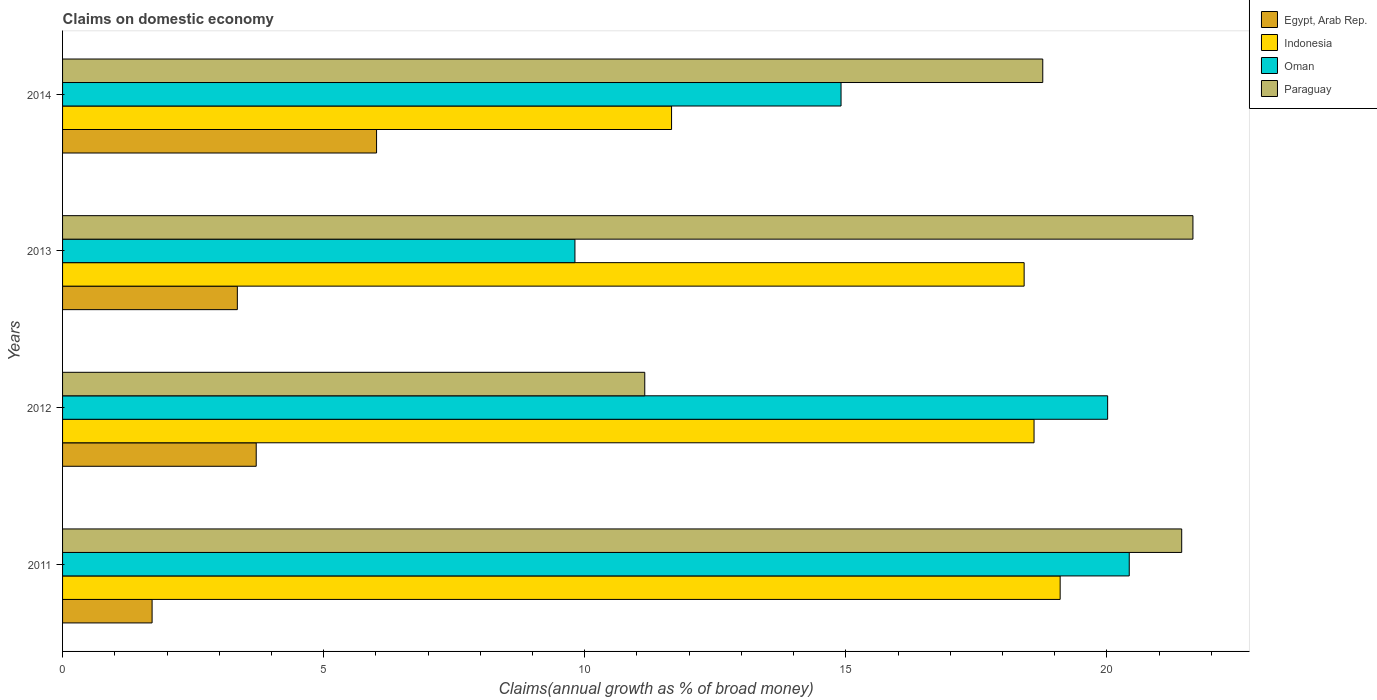How many different coloured bars are there?
Ensure brevity in your answer.  4. How many groups of bars are there?
Give a very brief answer. 4. Are the number of bars per tick equal to the number of legend labels?
Keep it short and to the point. Yes. How many bars are there on the 2nd tick from the top?
Your answer should be very brief. 4. What is the label of the 1st group of bars from the top?
Your answer should be very brief. 2014. What is the percentage of broad money claimed on domestic economy in Paraguay in 2011?
Your response must be concise. 21.43. Across all years, what is the maximum percentage of broad money claimed on domestic economy in Oman?
Keep it short and to the point. 20.43. Across all years, what is the minimum percentage of broad money claimed on domestic economy in Indonesia?
Ensure brevity in your answer.  11.66. In which year was the percentage of broad money claimed on domestic economy in Indonesia maximum?
Your response must be concise. 2011. What is the total percentage of broad money claimed on domestic economy in Egypt, Arab Rep. in the graph?
Give a very brief answer. 14.78. What is the difference between the percentage of broad money claimed on domestic economy in Indonesia in 2011 and that in 2014?
Your answer should be very brief. 7.44. What is the difference between the percentage of broad money claimed on domestic economy in Indonesia in 2014 and the percentage of broad money claimed on domestic economy in Oman in 2013?
Make the answer very short. 1.85. What is the average percentage of broad money claimed on domestic economy in Indonesia per year?
Ensure brevity in your answer.  16.95. In the year 2012, what is the difference between the percentage of broad money claimed on domestic economy in Indonesia and percentage of broad money claimed on domestic economy in Paraguay?
Your answer should be compact. 7.46. In how many years, is the percentage of broad money claimed on domestic economy in Oman greater than 4 %?
Ensure brevity in your answer.  4. What is the ratio of the percentage of broad money claimed on domestic economy in Egypt, Arab Rep. in 2012 to that in 2014?
Give a very brief answer. 0.62. What is the difference between the highest and the second highest percentage of broad money claimed on domestic economy in Indonesia?
Keep it short and to the point. 0.5. What is the difference between the highest and the lowest percentage of broad money claimed on domestic economy in Paraguay?
Your answer should be very brief. 10.5. Is the sum of the percentage of broad money claimed on domestic economy in Paraguay in 2013 and 2014 greater than the maximum percentage of broad money claimed on domestic economy in Indonesia across all years?
Make the answer very short. Yes. Is it the case that in every year, the sum of the percentage of broad money claimed on domestic economy in Oman and percentage of broad money claimed on domestic economy in Indonesia is greater than the sum of percentage of broad money claimed on domestic economy in Paraguay and percentage of broad money claimed on domestic economy in Egypt, Arab Rep.?
Your answer should be very brief. No. What does the 1st bar from the top in 2014 represents?
Offer a very short reply. Paraguay. What does the 4th bar from the bottom in 2011 represents?
Provide a short and direct response. Paraguay. Are the values on the major ticks of X-axis written in scientific E-notation?
Ensure brevity in your answer.  No. Does the graph contain grids?
Your response must be concise. No. How many legend labels are there?
Make the answer very short. 4. What is the title of the graph?
Your answer should be compact. Claims on domestic economy. What is the label or title of the X-axis?
Your answer should be very brief. Claims(annual growth as % of broad money). What is the Claims(annual growth as % of broad money) of Egypt, Arab Rep. in 2011?
Keep it short and to the point. 1.71. What is the Claims(annual growth as % of broad money) of Indonesia in 2011?
Make the answer very short. 19.1. What is the Claims(annual growth as % of broad money) of Oman in 2011?
Offer a terse response. 20.43. What is the Claims(annual growth as % of broad money) of Paraguay in 2011?
Keep it short and to the point. 21.43. What is the Claims(annual growth as % of broad money) in Egypt, Arab Rep. in 2012?
Your response must be concise. 3.71. What is the Claims(annual growth as % of broad money) of Indonesia in 2012?
Provide a short and direct response. 18.6. What is the Claims(annual growth as % of broad money) of Oman in 2012?
Offer a terse response. 20.01. What is the Claims(annual growth as % of broad money) in Paraguay in 2012?
Make the answer very short. 11.15. What is the Claims(annual growth as % of broad money) of Egypt, Arab Rep. in 2013?
Your response must be concise. 3.35. What is the Claims(annual growth as % of broad money) of Indonesia in 2013?
Offer a very short reply. 18.42. What is the Claims(annual growth as % of broad money) in Oman in 2013?
Your answer should be very brief. 9.81. What is the Claims(annual growth as % of broad money) of Paraguay in 2013?
Give a very brief answer. 21.65. What is the Claims(annual growth as % of broad money) in Egypt, Arab Rep. in 2014?
Your response must be concise. 6.01. What is the Claims(annual growth as % of broad money) in Indonesia in 2014?
Provide a short and direct response. 11.66. What is the Claims(annual growth as % of broad money) of Oman in 2014?
Ensure brevity in your answer.  14.91. What is the Claims(annual growth as % of broad money) in Paraguay in 2014?
Your response must be concise. 18.77. Across all years, what is the maximum Claims(annual growth as % of broad money) of Egypt, Arab Rep.?
Provide a short and direct response. 6.01. Across all years, what is the maximum Claims(annual growth as % of broad money) in Indonesia?
Your response must be concise. 19.1. Across all years, what is the maximum Claims(annual growth as % of broad money) in Oman?
Make the answer very short. 20.43. Across all years, what is the maximum Claims(annual growth as % of broad money) in Paraguay?
Make the answer very short. 21.65. Across all years, what is the minimum Claims(annual growth as % of broad money) of Egypt, Arab Rep.?
Your response must be concise. 1.71. Across all years, what is the minimum Claims(annual growth as % of broad money) in Indonesia?
Your answer should be compact. 11.66. Across all years, what is the minimum Claims(annual growth as % of broad money) of Oman?
Make the answer very short. 9.81. Across all years, what is the minimum Claims(annual growth as % of broad money) of Paraguay?
Offer a terse response. 11.15. What is the total Claims(annual growth as % of broad money) of Egypt, Arab Rep. in the graph?
Offer a very short reply. 14.78. What is the total Claims(annual growth as % of broad money) of Indonesia in the graph?
Your answer should be very brief. 67.79. What is the total Claims(annual growth as % of broad money) in Oman in the graph?
Your response must be concise. 65.16. What is the total Claims(annual growth as % of broad money) in Paraguay in the graph?
Your answer should be very brief. 73. What is the difference between the Claims(annual growth as % of broad money) in Egypt, Arab Rep. in 2011 and that in 2012?
Make the answer very short. -1.99. What is the difference between the Claims(annual growth as % of broad money) in Oman in 2011 and that in 2012?
Offer a terse response. 0.41. What is the difference between the Claims(annual growth as % of broad money) of Paraguay in 2011 and that in 2012?
Your response must be concise. 10.28. What is the difference between the Claims(annual growth as % of broad money) in Egypt, Arab Rep. in 2011 and that in 2013?
Your response must be concise. -1.63. What is the difference between the Claims(annual growth as % of broad money) of Indonesia in 2011 and that in 2013?
Keep it short and to the point. 0.69. What is the difference between the Claims(annual growth as % of broad money) of Oman in 2011 and that in 2013?
Provide a short and direct response. 10.62. What is the difference between the Claims(annual growth as % of broad money) of Paraguay in 2011 and that in 2013?
Provide a short and direct response. -0.22. What is the difference between the Claims(annual growth as % of broad money) of Egypt, Arab Rep. in 2011 and that in 2014?
Your response must be concise. -4.3. What is the difference between the Claims(annual growth as % of broad money) in Indonesia in 2011 and that in 2014?
Keep it short and to the point. 7.44. What is the difference between the Claims(annual growth as % of broad money) in Oman in 2011 and that in 2014?
Give a very brief answer. 5.52. What is the difference between the Claims(annual growth as % of broad money) in Paraguay in 2011 and that in 2014?
Offer a very short reply. 2.66. What is the difference between the Claims(annual growth as % of broad money) of Egypt, Arab Rep. in 2012 and that in 2013?
Offer a very short reply. 0.36. What is the difference between the Claims(annual growth as % of broad money) of Indonesia in 2012 and that in 2013?
Provide a short and direct response. 0.19. What is the difference between the Claims(annual growth as % of broad money) in Oman in 2012 and that in 2013?
Your answer should be compact. 10.2. What is the difference between the Claims(annual growth as % of broad money) in Paraguay in 2012 and that in 2013?
Your answer should be compact. -10.5. What is the difference between the Claims(annual growth as % of broad money) of Egypt, Arab Rep. in 2012 and that in 2014?
Offer a very short reply. -2.3. What is the difference between the Claims(annual growth as % of broad money) in Indonesia in 2012 and that in 2014?
Offer a very short reply. 6.94. What is the difference between the Claims(annual growth as % of broad money) of Oman in 2012 and that in 2014?
Offer a very short reply. 5.11. What is the difference between the Claims(annual growth as % of broad money) of Paraguay in 2012 and that in 2014?
Your response must be concise. -7.62. What is the difference between the Claims(annual growth as % of broad money) in Egypt, Arab Rep. in 2013 and that in 2014?
Your response must be concise. -2.67. What is the difference between the Claims(annual growth as % of broad money) in Indonesia in 2013 and that in 2014?
Offer a terse response. 6.75. What is the difference between the Claims(annual growth as % of broad money) in Oman in 2013 and that in 2014?
Provide a short and direct response. -5.1. What is the difference between the Claims(annual growth as % of broad money) in Paraguay in 2013 and that in 2014?
Your answer should be compact. 2.88. What is the difference between the Claims(annual growth as % of broad money) in Egypt, Arab Rep. in 2011 and the Claims(annual growth as % of broad money) in Indonesia in 2012?
Offer a very short reply. -16.89. What is the difference between the Claims(annual growth as % of broad money) in Egypt, Arab Rep. in 2011 and the Claims(annual growth as % of broad money) in Oman in 2012?
Make the answer very short. -18.3. What is the difference between the Claims(annual growth as % of broad money) of Egypt, Arab Rep. in 2011 and the Claims(annual growth as % of broad money) of Paraguay in 2012?
Provide a succinct answer. -9.44. What is the difference between the Claims(annual growth as % of broad money) of Indonesia in 2011 and the Claims(annual growth as % of broad money) of Oman in 2012?
Offer a very short reply. -0.91. What is the difference between the Claims(annual growth as % of broad money) of Indonesia in 2011 and the Claims(annual growth as % of broad money) of Paraguay in 2012?
Your response must be concise. 7.96. What is the difference between the Claims(annual growth as % of broad money) in Oman in 2011 and the Claims(annual growth as % of broad money) in Paraguay in 2012?
Ensure brevity in your answer.  9.28. What is the difference between the Claims(annual growth as % of broad money) in Egypt, Arab Rep. in 2011 and the Claims(annual growth as % of broad money) in Indonesia in 2013?
Provide a succinct answer. -16.7. What is the difference between the Claims(annual growth as % of broad money) of Egypt, Arab Rep. in 2011 and the Claims(annual growth as % of broad money) of Oman in 2013?
Your answer should be compact. -8.1. What is the difference between the Claims(annual growth as % of broad money) in Egypt, Arab Rep. in 2011 and the Claims(annual growth as % of broad money) in Paraguay in 2013?
Ensure brevity in your answer.  -19.93. What is the difference between the Claims(annual growth as % of broad money) in Indonesia in 2011 and the Claims(annual growth as % of broad money) in Oman in 2013?
Keep it short and to the point. 9.29. What is the difference between the Claims(annual growth as % of broad money) in Indonesia in 2011 and the Claims(annual growth as % of broad money) in Paraguay in 2013?
Your answer should be compact. -2.54. What is the difference between the Claims(annual growth as % of broad money) of Oman in 2011 and the Claims(annual growth as % of broad money) of Paraguay in 2013?
Offer a terse response. -1.22. What is the difference between the Claims(annual growth as % of broad money) in Egypt, Arab Rep. in 2011 and the Claims(annual growth as % of broad money) in Indonesia in 2014?
Keep it short and to the point. -9.95. What is the difference between the Claims(annual growth as % of broad money) of Egypt, Arab Rep. in 2011 and the Claims(annual growth as % of broad money) of Oman in 2014?
Keep it short and to the point. -13.19. What is the difference between the Claims(annual growth as % of broad money) of Egypt, Arab Rep. in 2011 and the Claims(annual growth as % of broad money) of Paraguay in 2014?
Provide a short and direct response. -17.06. What is the difference between the Claims(annual growth as % of broad money) of Indonesia in 2011 and the Claims(annual growth as % of broad money) of Oman in 2014?
Provide a succinct answer. 4.2. What is the difference between the Claims(annual growth as % of broad money) in Indonesia in 2011 and the Claims(annual growth as % of broad money) in Paraguay in 2014?
Your answer should be very brief. 0.33. What is the difference between the Claims(annual growth as % of broad money) of Oman in 2011 and the Claims(annual growth as % of broad money) of Paraguay in 2014?
Make the answer very short. 1.66. What is the difference between the Claims(annual growth as % of broad money) of Egypt, Arab Rep. in 2012 and the Claims(annual growth as % of broad money) of Indonesia in 2013?
Your answer should be very brief. -14.71. What is the difference between the Claims(annual growth as % of broad money) in Egypt, Arab Rep. in 2012 and the Claims(annual growth as % of broad money) in Oman in 2013?
Keep it short and to the point. -6.1. What is the difference between the Claims(annual growth as % of broad money) in Egypt, Arab Rep. in 2012 and the Claims(annual growth as % of broad money) in Paraguay in 2013?
Your response must be concise. -17.94. What is the difference between the Claims(annual growth as % of broad money) of Indonesia in 2012 and the Claims(annual growth as % of broad money) of Oman in 2013?
Ensure brevity in your answer.  8.79. What is the difference between the Claims(annual growth as % of broad money) in Indonesia in 2012 and the Claims(annual growth as % of broad money) in Paraguay in 2013?
Offer a very short reply. -3.04. What is the difference between the Claims(annual growth as % of broad money) in Oman in 2012 and the Claims(annual growth as % of broad money) in Paraguay in 2013?
Keep it short and to the point. -1.63. What is the difference between the Claims(annual growth as % of broad money) of Egypt, Arab Rep. in 2012 and the Claims(annual growth as % of broad money) of Indonesia in 2014?
Provide a succinct answer. -7.95. What is the difference between the Claims(annual growth as % of broad money) of Egypt, Arab Rep. in 2012 and the Claims(annual growth as % of broad money) of Oman in 2014?
Make the answer very short. -11.2. What is the difference between the Claims(annual growth as % of broad money) in Egypt, Arab Rep. in 2012 and the Claims(annual growth as % of broad money) in Paraguay in 2014?
Ensure brevity in your answer.  -15.06. What is the difference between the Claims(annual growth as % of broad money) in Indonesia in 2012 and the Claims(annual growth as % of broad money) in Oman in 2014?
Your answer should be compact. 3.7. What is the difference between the Claims(annual growth as % of broad money) of Indonesia in 2012 and the Claims(annual growth as % of broad money) of Paraguay in 2014?
Make the answer very short. -0.17. What is the difference between the Claims(annual growth as % of broad money) in Oman in 2012 and the Claims(annual growth as % of broad money) in Paraguay in 2014?
Your answer should be very brief. 1.24. What is the difference between the Claims(annual growth as % of broad money) of Egypt, Arab Rep. in 2013 and the Claims(annual growth as % of broad money) of Indonesia in 2014?
Ensure brevity in your answer.  -8.32. What is the difference between the Claims(annual growth as % of broad money) in Egypt, Arab Rep. in 2013 and the Claims(annual growth as % of broad money) in Oman in 2014?
Your answer should be very brief. -11.56. What is the difference between the Claims(annual growth as % of broad money) in Egypt, Arab Rep. in 2013 and the Claims(annual growth as % of broad money) in Paraguay in 2014?
Provide a short and direct response. -15.42. What is the difference between the Claims(annual growth as % of broad money) of Indonesia in 2013 and the Claims(annual growth as % of broad money) of Oman in 2014?
Your response must be concise. 3.51. What is the difference between the Claims(annual growth as % of broad money) of Indonesia in 2013 and the Claims(annual growth as % of broad money) of Paraguay in 2014?
Your answer should be very brief. -0.36. What is the difference between the Claims(annual growth as % of broad money) of Oman in 2013 and the Claims(annual growth as % of broad money) of Paraguay in 2014?
Offer a very short reply. -8.96. What is the average Claims(annual growth as % of broad money) of Egypt, Arab Rep. per year?
Provide a short and direct response. 3.7. What is the average Claims(annual growth as % of broad money) of Indonesia per year?
Ensure brevity in your answer.  16.95. What is the average Claims(annual growth as % of broad money) in Oman per year?
Ensure brevity in your answer.  16.29. What is the average Claims(annual growth as % of broad money) of Paraguay per year?
Offer a very short reply. 18.25. In the year 2011, what is the difference between the Claims(annual growth as % of broad money) of Egypt, Arab Rep. and Claims(annual growth as % of broad money) of Indonesia?
Make the answer very short. -17.39. In the year 2011, what is the difference between the Claims(annual growth as % of broad money) of Egypt, Arab Rep. and Claims(annual growth as % of broad money) of Oman?
Give a very brief answer. -18.71. In the year 2011, what is the difference between the Claims(annual growth as % of broad money) of Egypt, Arab Rep. and Claims(annual growth as % of broad money) of Paraguay?
Your answer should be compact. -19.72. In the year 2011, what is the difference between the Claims(annual growth as % of broad money) in Indonesia and Claims(annual growth as % of broad money) in Oman?
Provide a succinct answer. -1.32. In the year 2011, what is the difference between the Claims(annual growth as % of broad money) of Indonesia and Claims(annual growth as % of broad money) of Paraguay?
Ensure brevity in your answer.  -2.33. In the year 2011, what is the difference between the Claims(annual growth as % of broad money) in Oman and Claims(annual growth as % of broad money) in Paraguay?
Your answer should be compact. -1. In the year 2012, what is the difference between the Claims(annual growth as % of broad money) of Egypt, Arab Rep. and Claims(annual growth as % of broad money) of Indonesia?
Offer a terse response. -14.9. In the year 2012, what is the difference between the Claims(annual growth as % of broad money) of Egypt, Arab Rep. and Claims(annual growth as % of broad money) of Oman?
Your answer should be compact. -16.31. In the year 2012, what is the difference between the Claims(annual growth as % of broad money) in Egypt, Arab Rep. and Claims(annual growth as % of broad money) in Paraguay?
Keep it short and to the point. -7.44. In the year 2012, what is the difference between the Claims(annual growth as % of broad money) in Indonesia and Claims(annual growth as % of broad money) in Oman?
Ensure brevity in your answer.  -1.41. In the year 2012, what is the difference between the Claims(annual growth as % of broad money) in Indonesia and Claims(annual growth as % of broad money) in Paraguay?
Your answer should be very brief. 7.46. In the year 2012, what is the difference between the Claims(annual growth as % of broad money) of Oman and Claims(annual growth as % of broad money) of Paraguay?
Your response must be concise. 8.86. In the year 2013, what is the difference between the Claims(annual growth as % of broad money) of Egypt, Arab Rep. and Claims(annual growth as % of broad money) of Indonesia?
Give a very brief answer. -15.07. In the year 2013, what is the difference between the Claims(annual growth as % of broad money) of Egypt, Arab Rep. and Claims(annual growth as % of broad money) of Oman?
Your response must be concise. -6.47. In the year 2013, what is the difference between the Claims(annual growth as % of broad money) in Egypt, Arab Rep. and Claims(annual growth as % of broad money) in Paraguay?
Make the answer very short. -18.3. In the year 2013, what is the difference between the Claims(annual growth as % of broad money) of Indonesia and Claims(annual growth as % of broad money) of Oman?
Ensure brevity in your answer.  8.6. In the year 2013, what is the difference between the Claims(annual growth as % of broad money) of Indonesia and Claims(annual growth as % of broad money) of Paraguay?
Offer a very short reply. -3.23. In the year 2013, what is the difference between the Claims(annual growth as % of broad money) in Oman and Claims(annual growth as % of broad money) in Paraguay?
Your response must be concise. -11.84. In the year 2014, what is the difference between the Claims(annual growth as % of broad money) in Egypt, Arab Rep. and Claims(annual growth as % of broad money) in Indonesia?
Your answer should be compact. -5.65. In the year 2014, what is the difference between the Claims(annual growth as % of broad money) of Egypt, Arab Rep. and Claims(annual growth as % of broad money) of Oman?
Give a very brief answer. -8.9. In the year 2014, what is the difference between the Claims(annual growth as % of broad money) of Egypt, Arab Rep. and Claims(annual growth as % of broad money) of Paraguay?
Offer a terse response. -12.76. In the year 2014, what is the difference between the Claims(annual growth as % of broad money) in Indonesia and Claims(annual growth as % of broad money) in Oman?
Ensure brevity in your answer.  -3.25. In the year 2014, what is the difference between the Claims(annual growth as % of broad money) of Indonesia and Claims(annual growth as % of broad money) of Paraguay?
Provide a short and direct response. -7.11. In the year 2014, what is the difference between the Claims(annual growth as % of broad money) in Oman and Claims(annual growth as % of broad money) in Paraguay?
Your answer should be compact. -3.86. What is the ratio of the Claims(annual growth as % of broad money) of Egypt, Arab Rep. in 2011 to that in 2012?
Keep it short and to the point. 0.46. What is the ratio of the Claims(annual growth as % of broad money) in Indonesia in 2011 to that in 2012?
Your answer should be very brief. 1.03. What is the ratio of the Claims(annual growth as % of broad money) of Oman in 2011 to that in 2012?
Your answer should be compact. 1.02. What is the ratio of the Claims(annual growth as % of broad money) of Paraguay in 2011 to that in 2012?
Provide a short and direct response. 1.92. What is the ratio of the Claims(annual growth as % of broad money) of Egypt, Arab Rep. in 2011 to that in 2013?
Ensure brevity in your answer.  0.51. What is the ratio of the Claims(annual growth as % of broad money) in Indonesia in 2011 to that in 2013?
Make the answer very short. 1.04. What is the ratio of the Claims(annual growth as % of broad money) in Oman in 2011 to that in 2013?
Your answer should be compact. 2.08. What is the ratio of the Claims(annual growth as % of broad money) in Paraguay in 2011 to that in 2013?
Your response must be concise. 0.99. What is the ratio of the Claims(annual growth as % of broad money) of Egypt, Arab Rep. in 2011 to that in 2014?
Ensure brevity in your answer.  0.29. What is the ratio of the Claims(annual growth as % of broad money) in Indonesia in 2011 to that in 2014?
Give a very brief answer. 1.64. What is the ratio of the Claims(annual growth as % of broad money) of Oman in 2011 to that in 2014?
Provide a short and direct response. 1.37. What is the ratio of the Claims(annual growth as % of broad money) in Paraguay in 2011 to that in 2014?
Give a very brief answer. 1.14. What is the ratio of the Claims(annual growth as % of broad money) in Egypt, Arab Rep. in 2012 to that in 2013?
Give a very brief answer. 1.11. What is the ratio of the Claims(annual growth as % of broad money) in Indonesia in 2012 to that in 2013?
Provide a succinct answer. 1.01. What is the ratio of the Claims(annual growth as % of broad money) of Oman in 2012 to that in 2013?
Provide a short and direct response. 2.04. What is the ratio of the Claims(annual growth as % of broad money) in Paraguay in 2012 to that in 2013?
Ensure brevity in your answer.  0.52. What is the ratio of the Claims(annual growth as % of broad money) of Egypt, Arab Rep. in 2012 to that in 2014?
Your answer should be very brief. 0.62. What is the ratio of the Claims(annual growth as % of broad money) in Indonesia in 2012 to that in 2014?
Ensure brevity in your answer.  1.6. What is the ratio of the Claims(annual growth as % of broad money) in Oman in 2012 to that in 2014?
Provide a succinct answer. 1.34. What is the ratio of the Claims(annual growth as % of broad money) of Paraguay in 2012 to that in 2014?
Make the answer very short. 0.59. What is the ratio of the Claims(annual growth as % of broad money) in Egypt, Arab Rep. in 2013 to that in 2014?
Offer a very short reply. 0.56. What is the ratio of the Claims(annual growth as % of broad money) in Indonesia in 2013 to that in 2014?
Provide a short and direct response. 1.58. What is the ratio of the Claims(annual growth as % of broad money) in Oman in 2013 to that in 2014?
Provide a short and direct response. 0.66. What is the ratio of the Claims(annual growth as % of broad money) of Paraguay in 2013 to that in 2014?
Your response must be concise. 1.15. What is the difference between the highest and the second highest Claims(annual growth as % of broad money) of Egypt, Arab Rep.?
Your answer should be very brief. 2.3. What is the difference between the highest and the second highest Claims(annual growth as % of broad money) in Oman?
Keep it short and to the point. 0.41. What is the difference between the highest and the second highest Claims(annual growth as % of broad money) of Paraguay?
Provide a succinct answer. 0.22. What is the difference between the highest and the lowest Claims(annual growth as % of broad money) in Egypt, Arab Rep.?
Your answer should be very brief. 4.3. What is the difference between the highest and the lowest Claims(annual growth as % of broad money) of Indonesia?
Your answer should be very brief. 7.44. What is the difference between the highest and the lowest Claims(annual growth as % of broad money) in Oman?
Keep it short and to the point. 10.62. What is the difference between the highest and the lowest Claims(annual growth as % of broad money) of Paraguay?
Provide a short and direct response. 10.5. 